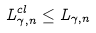<formula> <loc_0><loc_0><loc_500><loc_500>L _ { \gamma , n } ^ { c l } \leq L _ { \gamma , n }</formula> 